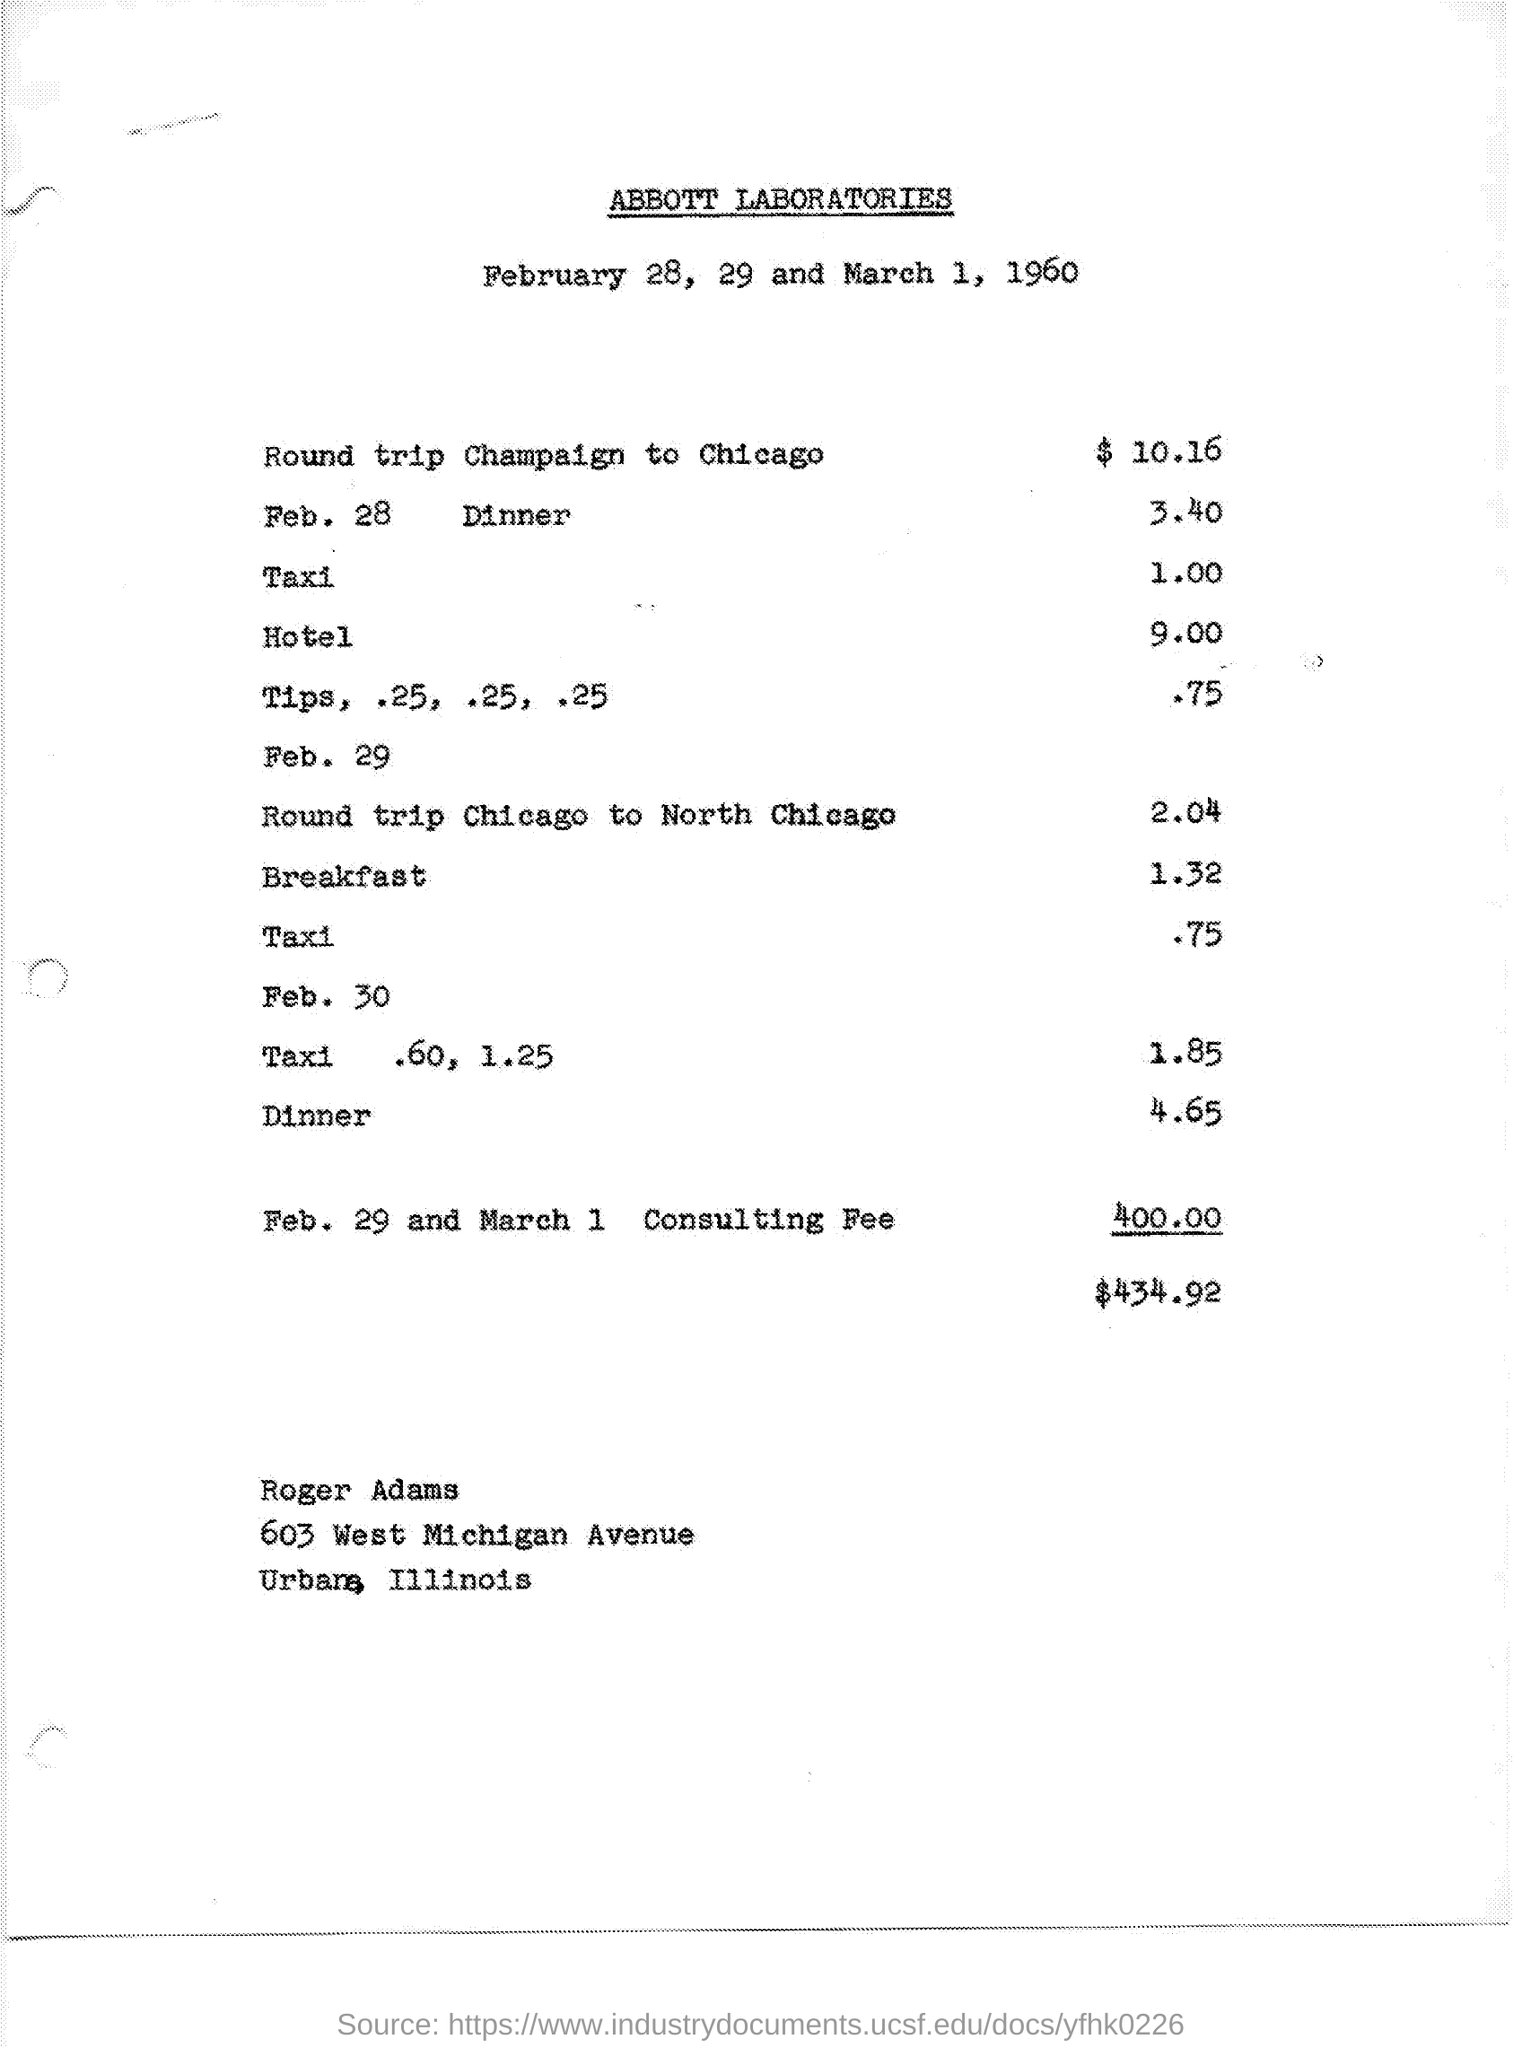List a handful of essential elements in this visual. The cost of a round trip from Chicago to North Chicago is $2.04. The cost of the dinner on February 28 is 40% The title of the document is "ABBOTT LABORATORIES. The cost of a round trip from Champaign to Chicago is $10.16. 